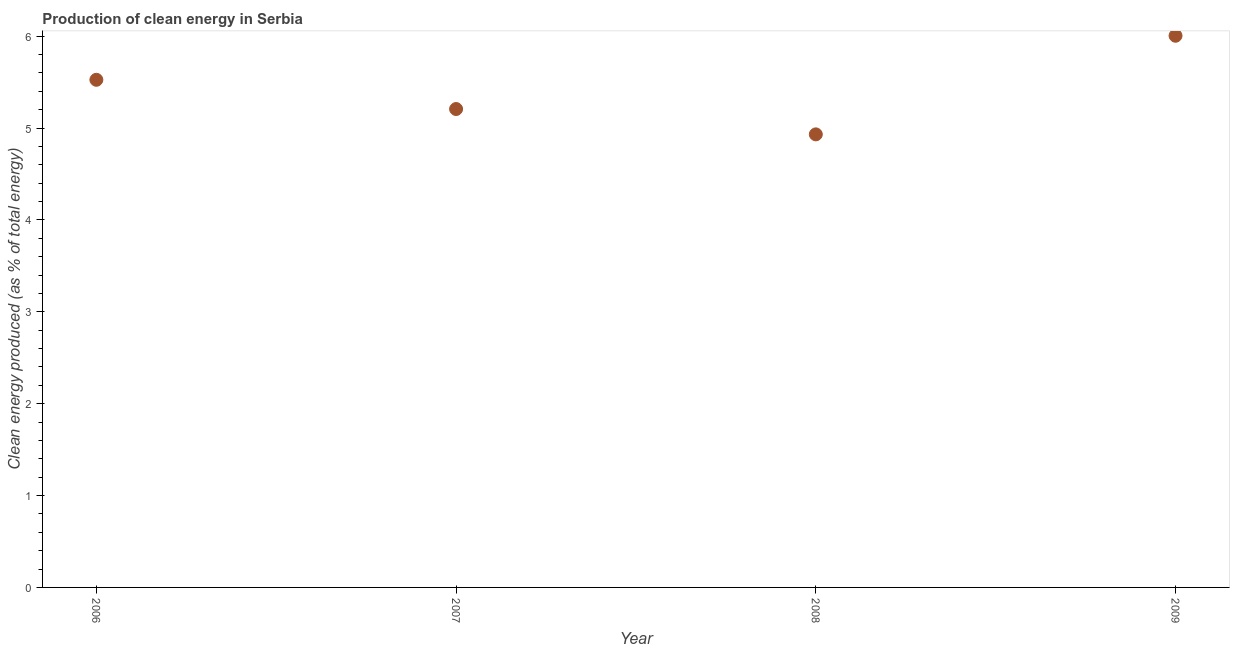What is the production of clean energy in 2006?
Ensure brevity in your answer.  5.53. Across all years, what is the maximum production of clean energy?
Your answer should be very brief. 6.01. Across all years, what is the minimum production of clean energy?
Your answer should be very brief. 4.93. In which year was the production of clean energy maximum?
Give a very brief answer. 2009. What is the sum of the production of clean energy?
Provide a short and direct response. 21.67. What is the difference between the production of clean energy in 2006 and 2008?
Your response must be concise. 0.59. What is the average production of clean energy per year?
Keep it short and to the point. 5.42. What is the median production of clean energy?
Provide a short and direct response. 5.37. In how many years, is the production of clean energy greater than 2.4 %?
Your response must be concise. 4. Do a majority of the years between 2009 and 2006 (inclusive) have production of clean energy greater than 0.2 %?
Offer a terse response. Yes. What is the ratio of the production of clean energy in 2006 to that in 2009?
Ensure brevity in your answer.  0.92. Is the difference between the production of clean energy in 2007 and 2009 greater than the difference between any two years?
Your answer should be compact. No. What is the difference between the highest and the second highest production of clean energy?
Provide a succinct answer. 0.48. Is the sum of the production of clean energy in 2006 and 2008 greater than the maximum production of clean energy across all years?
Offer a terse response. Yes. What is the difference between the highest and the lowest production of clean energy?
Your answer should be very brief. 1.07. In how many years, is the production of clean energy greater than the average production of clean energy taken over all years?
Offer a terse response. 2. How many dotlines are there?
Provide a short and direct response. 1. What is the difference between two consecutive major ticks on the Y-axis?
Your response must be concise. 1. Are the values on the major ticks of Y-axis written in scientific E-notation?
Your answer should be very brief. No. Does the graph contain grids?
Offer a terse response. No. What is the title of the graph?
Offer a terse response. Production of clean energy in Serbia. What is the label or title of the Y-axis?
Make the answer very short. Clean energy produced (as % of total energy). What is the Clean energy produced (as % of total energy) in 2006?
Ensure brevity in your answer.  5.53. What is the Clean energy produced (as % of total energy) in 2007?
Your answer should be very brief. 5.21. What is the Clean energy produced (as % of total energy) in 2008?
Give a very brief answer. 4.93. What is the Clean energy produced (as % of total energy) in 2009?
Your answer should be compact. 6.01. What is the difference between the Clean energy produced (as % of total energy) in 2006 and 2007?
Keep it short and to the point. 0.32. What is the difference between the Clean energy produced (as % of total energy) in 2006 and 2008?
Your response must be concise. 0.59. What is the difference between the Clean energy produced (as % of total energy) in 2006 and 2009?
Make the answer very short. -0.48. What is the difference between the Clean energy produced (as % of total energy) in 2007 and 2008?
Ensure brevity in your answer.  0.28. What is the difference between the Clean energy produced (as % of total energy) in 2007 and 2009?
Make the answer very short. -0.8. What is the difference between the Clean energy produced (as % of total energy) in 2008 and 2009?
Offer a very short reply. -1.07. What is the ratio of the Clean energy produced (as % of total energy) in 2006 to that in 2007?
Give a very brief answer. 1.06. What is the ratio of the Clean energy produced (as % of total energy) in 2006 to that in 2008?
Provide a short and direct response. 1.12. What is the ratio of the Clean energy produced (as % of total energy) in 2006 to that in 2009?
Your answer should be compact. 0.92. What is the ratio of the Clean energy produced (as % of total energy) in 2007 to that in 2008?
Your answer should be compact. 1.06. What is the ratio of the Clean energy produced (as % of total energy) in 2007 to that in 2009?
Keep it short and to the point. 0.87. What is the ratio of the Clean energy produced (as % of total energy) in 2008 to that in 2009?
Your answer should be compact. 0.82. 